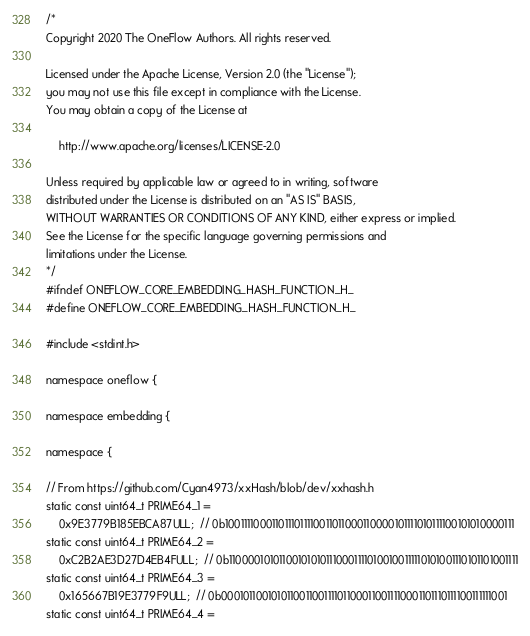<code> <loc_0><loc_0><loc_500><loc_500><_Cuda_>/*
Copyright 2020 The OneFlow Authors. All rights reserved.

Licensed under the Apache License, Version 2.0 (the "License");
you may not use this file except in compliance with the License.
You may obtain a copy of the License at

    http://www.apache.org/licenses/LICENSE-2.0

Unless required by applicable law or agreed to in writing, software
distributed under the License is distributed on an "AS IS" BASIS,
WITHOUT WARRANTIES OR CONDITIONS OF ANY KIND, either express or implied.
See the License for the specific language governing permissions and
limitations under the License.
*/
#ifndef ONEFLOW_CORE_EMBEDDING_HASH_FUNCTION_H_
#define ONEFLOW_CORE_EMBEDDING_HASH_FUNCTION_H_

#include <stdint.h>

namespace oneflow {

namespace embedding {

namespace {

// From https://github.com/Cyan4973/xxHash/blob/dev/xxhash.h
static const uint64_t PRIME64_1 =
    0x9E3779B185EBCA87ULL;  // 0b1001111000110111011110011011000110000101111010111100101010000111
static const uint64_t PRIME64_2 =
    0xC2B2AE3D27D4EB4FULL;  // 0b1100001010110010101011100011110100100111110101001110101101001111
static const uint64_t PRIME64_3 =
    0x165667B19E3779F9ULL;  // 0b0001011001010110011001111011000110011110001101110111100111111001
static const uint64_t PRIME64_4 =</code> 